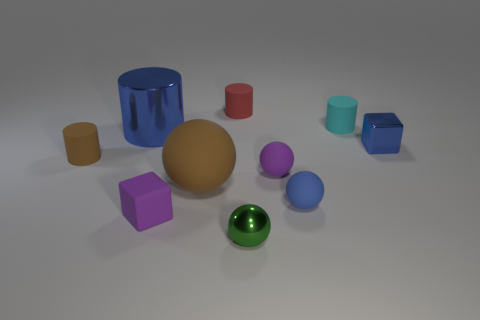What is the size of the shiny cylinder?
Your answer should be very brief. Large. Are there an equal number of cyan objects on the left side of the big sphere and large brown metal cylinders?
Your answer should be very brief. Yes. How many other things are the same color as the rubber block?
Give a very brief answer. 1. The tiny thing that is behind the metal cube and left of the cyan matte cylinder is what color?
Ensure brevity in your answer.  Red. What is the size of the cylinder to the right of the tiny shiny thing in front of the brown rubber object behind the big brown rubber sphere?
Make the answer very short. Small. How many things are matte cylinders that are on the right side of the red rubber thing or metal objects left of the large brown ball?
Your response must be concise. 2. What shape is the big brown thing?
Your answer should be compact. Sphere. How many other objects are the same material as the brown cylinder?
Offer a very short reply. 6. There is a brown object that is the same shape as the green object; what size is it?
Make the answer very short. Large. There is a block that is in front of the small cube that is on the right side of the brown rubber object that is in front of the brown cylinder; what is it made of?
Ensure brevity in your answer.  Rubber. 